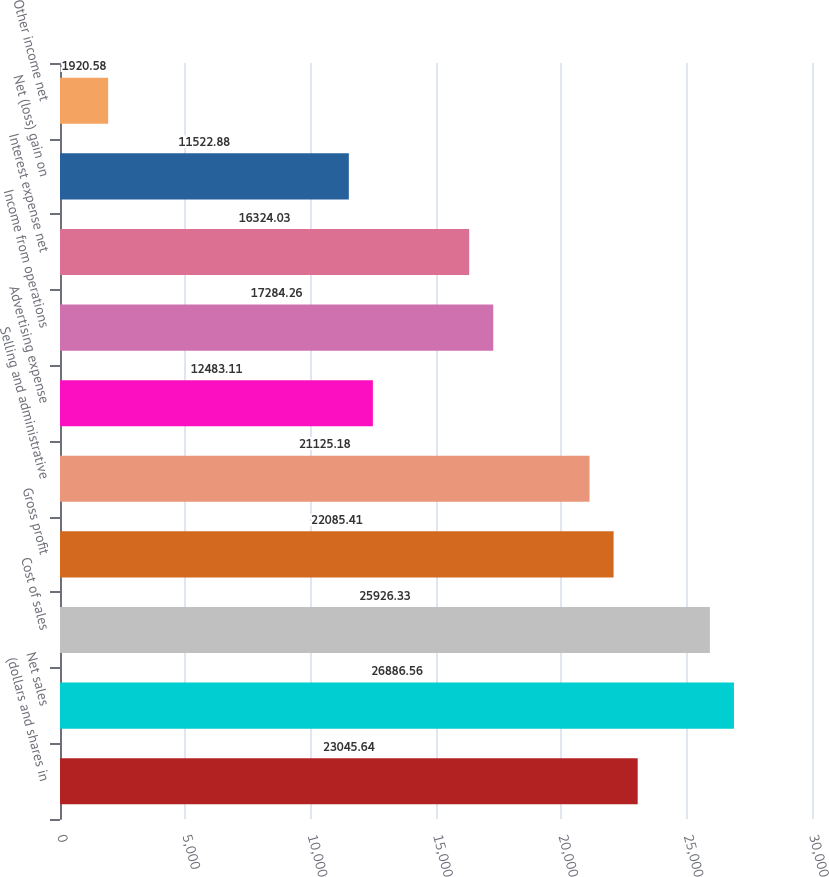Convert chart to OTSL. <chart><loc_0><loc_0><loc_500><loc_500><bar_chart><fcel>(dollars and shares in<fcel>Net sales<fcel>Cost of sales<fcel>Gross profit<fcel>Selling and administrative<fcel>Advertising expense<fcel>Income from operations<fcel>Interest expense net<fcel>Net (loss) gain on<fcel>Other income net<nl><fcel>23045.6<fcel>26886.6<fcel>25926.3<fcel>22085.4<fcel>21125.2<fcel>12483.1<fcel>17284.3<fcel>16324<fcel>11522.9<fcel>1920.58<nl></chart> 